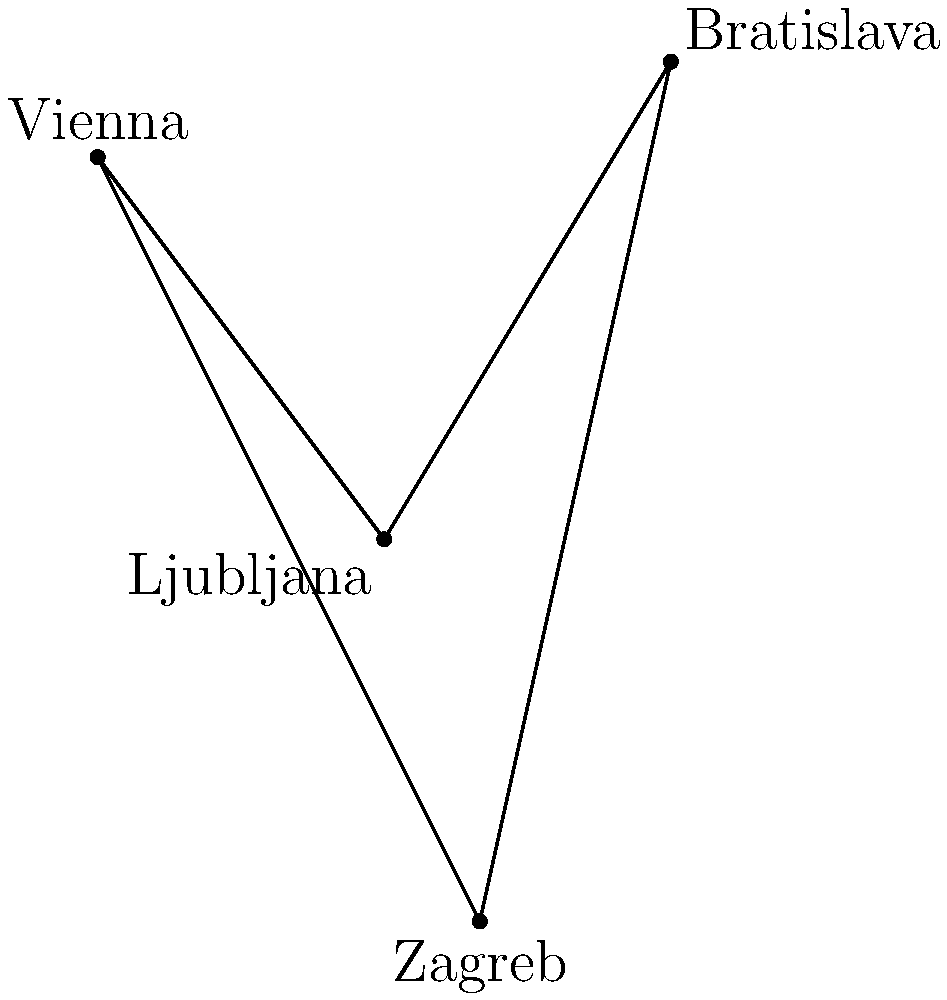On a simplified map of Central Europe, the capitals of four smaller EU countries are represented as points: Vienna (Austria), Ljubljana (Slovenia), Bratislava (Slovakia), and Zagreb (Croatia). What is the shortest path connecting all these capitals, and what is its total length if the distance between Vienna and Zagreb is 200 km? To find the shortest path connecting all four capitals, we need to follow these steps:

1. Recognize that this is a variation of the Traveling Salesman Problem.
2. For four points, there are only three possible paths to consider:
   a) Vienna - Ljubljana - Bratislava - Zagreb
   b) Vienna - Bratislava - Ljubljana - Zagreb
   c) Vienna - Zagreb - Ljubljana - Bratislava

3. The shortest path will be the one that forms a convex quadrilateral without any intersecting lines.

4. From the diagram, we can see that the path Vienna - Ljubljana - Zagreb - Bratislava forms a convex quadrilateral without intersections.

5. To calculate the total length:
   a) We're given that Vienna to Zagreb is 200 km.
   b) This forms the diagonal of our quadrilateral.
   c) In a convex quadrilateral, the sum of any three sides is always greater than the diagonal.
   d) Therefore, the path Vienna - Ljubljana - Zagreb - Bratislava - Vienna is shorter than any path including the diagonal.

6. The exact length cannot be calculated without more information, but we know it's less than 400 km (twice the diagonal).
Answer: Vienna - Ljubljana - Zagreb - Bratislava - Vienna, < 400 km 